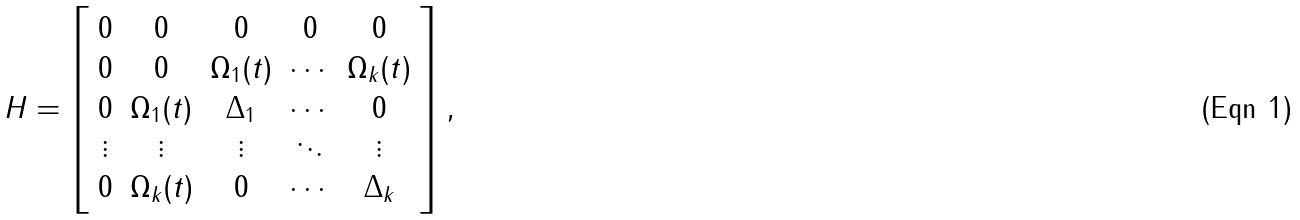<formula> <loc_0><loc_0><loc_500><loc_500>H = \left [ \begin{array} { c c c c c } 0 & 0 & 0 & 0 & 0 \\ 0 & 0 & \Omega _ { 1 } ( t ) & \cdots & \Omega _ { k } ( t ) \\ 0 & \Omega _ { 1 } ( t ) & \Delta _ { 1 } & \cdots & 0 \\ \vdots & \vdots & \vdots & \ddots & \vdots \\ 0 & \Omega _ { k } ( t ) & 0 & \cdots & \Delta _ { k } \\ \end{array} \right ] ,</formula> 